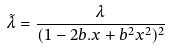<formula> <loc_0><loc_0><loc_500><loc_500>\tilde { \lambda } = \frac { \lambda } { ( 1 - 2 b . x + b ^ { 2 } x ^ { 2 } ) ^ { 2 } }</formula> 